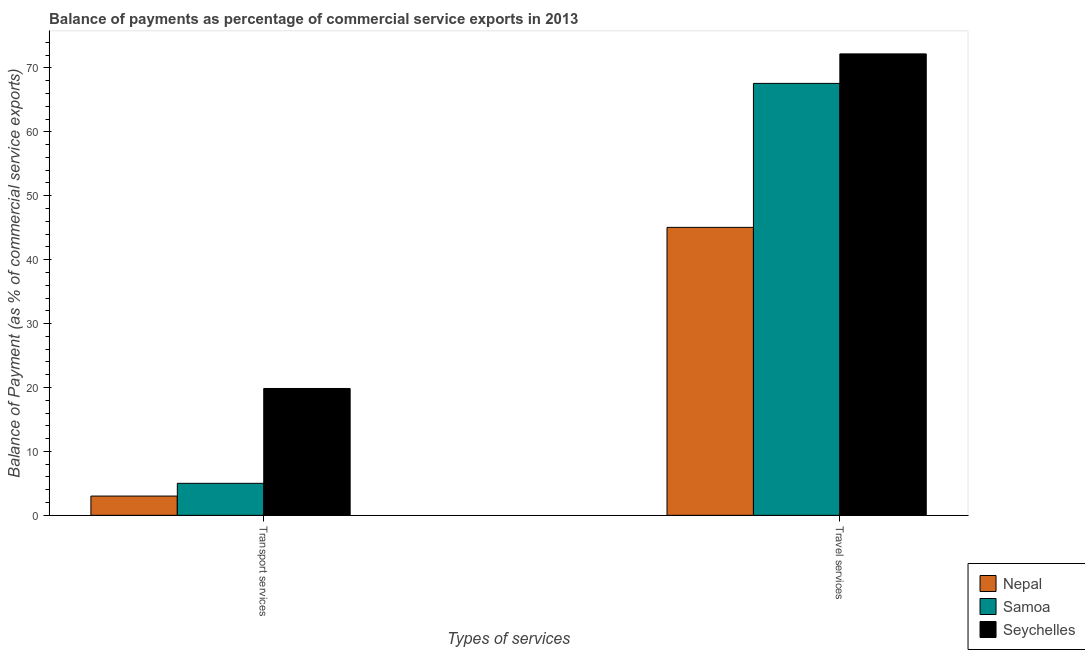Are the number of bars on each tick of the X-axis equal?
Offer a very short reply. Yes. How many bars are there on the 2nd tick from the left?
Your answer should be very brief. 3. How many bars are there on the 1st tick from the right?
Provide a succinct answer. 3. What is the label of the 2nd group of bars from the left?
Provide a succinct answer. Travel services. What is the balance of payments of transport services in Samoa?
Make the answer very short. 5.01. Across all countries, what is the maximum balance of payments of transport services?
Offer a terse response. 19.85. Across all countries, what is the minimum balance of payments of travel services?
Your response must be concise. 45.05. In which country was the balance of payments of transport services maximum?
Give a very brief answer. Seychelles. In which country was the balance of payments of travel services minimum?
Ensure brevity in your answer.  Nepal. What is the total balance of payments of travel services in the graph?
Your response must be concise. 184.81. What is the difference between the balance of payments of transport services in Samoa and that in Seychelles?
Your response must be concise. -14.84. What is the difference between the balance of payments of travel services in Samoa and the balance of payments of transport services in Seychelles?
Provide a succinct answer. 47.73. What is the average balance of payments of transport services per country?
Make the answer very short. 9.29. What is the difference between the balance of payments of transport services and balance of payments of travel services in Samoa?
Provide a short and direct response. -62.56. What is the ratio of the balance of payments of transport services in Nepal to that in Samoa?
Make the answer very short. 0.6. Is the balance of payments of transport services in Samoa less than that in Nepal?
Provide a succinct answer. No. What does the 1st bar from the left in Travel services represents?
Provide a short and direct response. Nepal. What does the 1st bar from the right in Travel services represents?
Provide a succinct answer. Seychelles. Are the values on the major ticks of Y-axis written in scientific E-notation?
Make the answer very short. No. Does the graph contain any zero values?
Provide a succinct answer. No. Does the graph contain grids?
Offer a very short reply. No. Where does the legend appear in the graph?
Your answer should be compact. Bottom right. How many legend labels are there?
Provide a succinct answer. 3. What is the title of the graph?
Offer a very short reply. Balance of payments as percentage of commercial service exports in 2013. Does "Sao Tome and Principe" appear as one of the legend labels in the graph?
Your answer should be very brief. No. What is the label or title of the X-axis?
Your answer should be compact. Types of services. What is the label or title of the Y-axis?
Your answer should be very brief. Balance of Payment (as % of commercial service exports). What is the Balance of Payment (as % of commercial service exports) of Nepal in Transport services?
Your response must be concise. 3.01. What is the Balance of Payment (as % of commercial service exports) in Samoa in Transport services?
Make the answer very short. 5.01. What is the Balance of Payment (as % of commercial service exports) in Seychelles in Transport services?
Ensure brevity in your answer.  19.85. What is the Balance of Payment (as % of commercial service exports) in Nepal in Travel services?
Keep it short and to the point. 45.05. What is the Balance of Payment (as % of commercial service exports) of Samoa in Travel services?
Ensure brevity in your answer.  67.57. What is the Balance of Payment (as % of commercial service exports) in Seychelles in Travel services?
Offer a very short reply. 72.19. Across all Types of services, what is the maximum Balance of Payment (as % of commercial service exports) of Nepal?
Your response must be concise. 45.05. Across all Types of services, what is the maximum Balance of Payment (as % of commercial service exports) of Samoa?
Your answer should be very brief. 67.57. Across all Types of services, what is the maximum Balance of Payment (as % of commercial service exports) in Seychelles?
Ensure brevity in your answer.  72.19. Across all Types of services, what is the minimum Balance of Payment (as % of commercial service exports) in Nepal?
Provide a short and direct response. 3.01. Across all Types of services, what is the minimum Balance of Payment (as % of commercial service exports) in Samoa?
Offer a very short reply. 5.01. Across all Types of services, what is the minimum Balance of Payment (as % of commercial service exports) in Seychelles?
Your answer should be compact. 19.85. What is the total Balance of Payment (as % of commercial service exports) in Nepal in the graph?
Ensure brevity in your answer.  48.06. What is the total Balance of Payment (as % of commercial service exports) in Samoa in the graph?
Offer a very short reply. 72.58. What is the total Balance of Payment (as % of commercial service exports) of Seychelles in the graph?
Keep it short and to the point. 92.04. What is the difference between the Balance of Payment (as % of commercial service exports) of Nepal in Transport services and that in Travel services?
Provide a short and direct response. -42.04. What is the difference between the Balance of Payment (as % of commercial service exports) in Samoa in Transport services and that in Travel services?
Your answer should be compact. -62.56. What is the difference between the Balance of Payment (as % of commercial service exports) in Seychelles in Transport services and that in Travel services?
Offer a very short reply. -52.34. What is the difference between the Balance of Payment (as % of commercial service exports) in Nepal in Transport services and the Balance of Payment (as % of commercial service exports) in Samoa in Travel services?
Your response must be concise. -64.56. What is the difference between the Balance of Payment (as % of commercial service exports) of Nepal in Transport services and the Balance of Payment (as % of commercial service exports) of Seychelles in Travel services?
Offer a terse response. -69.17. What is the difference between the Balance of Payment (as % of commercial service exports) in Samoa in Transport services and the Balance of Payment (as % of commercial service exports) in Seychelles in Travel services?
Give a very brief answer. -67.18. What is the average Balance of Payment (as % of commercial service exports) in Nepal per Types of services?
Ensure brevity in your answer.  24.03. What is the average Balance of Payment (as % of commercial service exports) of Samoa per Types of services?
Offer a terse response. 36.29. What is the average Balance of Payment (as % of commercial service exports) of Seychelles per Types of services?
Your response must be concise. 46.02. What is the difference between the Balance of Payment (as % of commercial service exports) of Nepal and Balance of Payment (as % of commercial service exports) of Samoa in Transport services?
Offer a terse response. -1.99. What is the difference between the Balance of Payment (as % of commercial service exports) of Nepal and Balance of Payment (as % of commercial service exports) of Seychelles in Transport services?
Offer a terse response. -16.83. What is the difference between the Balance of Payment (as % of commercial service exports) in Samoa and Balance of Payment (as % of commercial service exports) in Seychelles in Transport services?
Keep it short and to the point. -14.84. What is the difference between the Balance of Payment (as % of commercial service exports) of Nepal and Balance of Payment (as % of commercial service exports) of Samoa in Travel services?
Provide a succinct answer. -22.52. What is the difference between the Balance of Payment (as % of commercial service exports) of Nepal and Balance of Payment (as % of commercial service exports) of Seychelles in Travel services?
Offer a terse response. -27.14. What is the difference between the Balance of Payment (as % of commercial service exports) in Samoa and Balance of Payment (as % of commercial service exports) in Seychelles in Travel services?
Provide a succinct answer. -4.62. What is the ratio of the Balance of Payment (as % of commercial service exports) in Nepal in Transport services to that in Travel services?
Your answer should be very brief. 0.07. What is the ratio of the Balance of Payment (as % of commercial service exports) in Samoa in Transport services to that in Travel services?
Keep it short and to the point. 0.07. What is the ratio of the Balance of Payment (as % of commercial service exports) in Seychelles in Transport services to that in Travel services?
Keep it short and to the point. 0.27. What is the difference between the highest and the second highest Balance of Payment (as % of commercial service exports) in Nepal?
Make the answer very short. 42.04. What is the difference between the highest and the second highest Balance of Payment (as % of commercial service exports) in Samoa?
Provide a short and direct response. 62.56. What is the difference between the highest and the second highest Balance of Payment (as % of commercial service exports) of Seychelles?
Your response must be concise. 52.34. What is the difference between the highest and the lowest Balance of Payment (as % of commercial service exports) in Nepal?
Your response must be concise. 42.04. What is the difference between the highest and the lowest Balance of Payment (as % of commercial service exports) in Samoa?
Your answer should be compact. 62.56. What is the difference between the highest and the lowest Balance of Payment (as % of commercial service exports) of Seychelles?
Give a very brief answer. 52.34. 